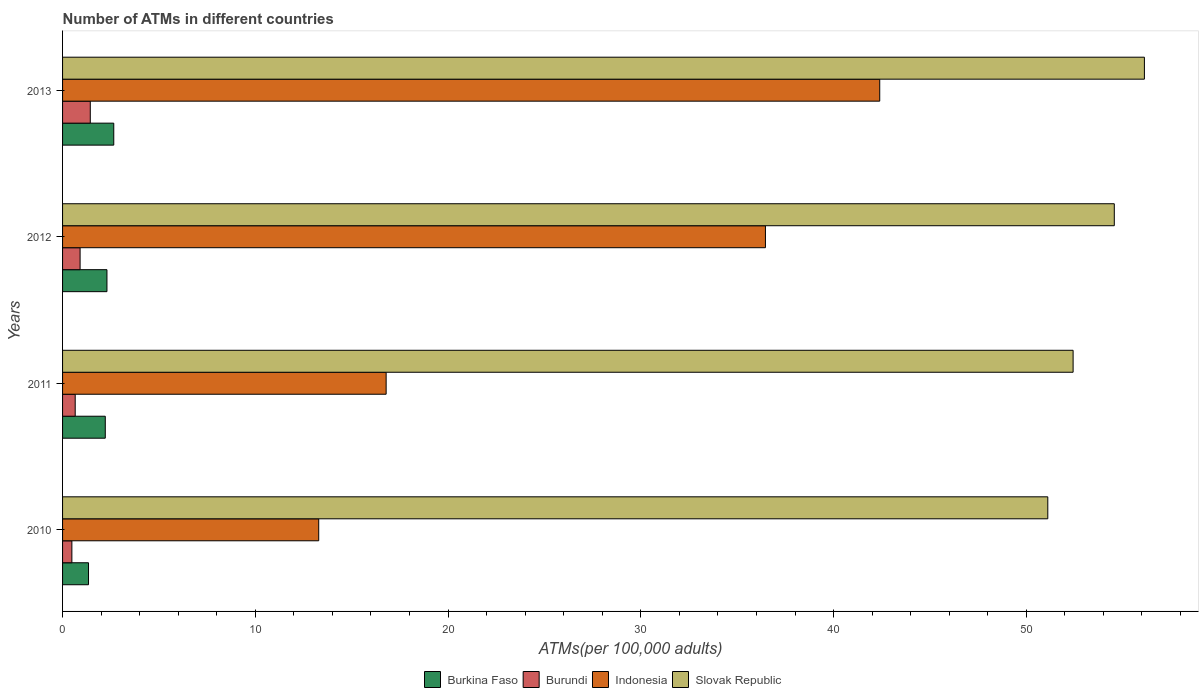In how many cases, is the number of bars for a given year not equal to the number of legend labels?
Ensure brevity in your answer.  0. What is the number of ATMs in Burkina Faso in 2013?
Ensure brevity in your answer.  2.66. Across all years, what is the maximum number of ATMs in Burundi?
Your response must be concise. 1.44. Across all years, what is the minimum number of ATMs in Burundi?
Your answer should be very brief. 0.48. What is the total number of ATMs in Indonesia in the graph?
Offer a very short reply. 108.94. What is the difference between the number of ATMs in Slovak Republic in 2012 and that in 2013?
Offer a very short reply. -1.56. What is the difference between the number of ATMs in Indonesia in 2011 and the number of ATMs in Burundi in 2012?
Keep it short and to the point. 15.88. What is the average number of ATMs in Indonesia per year?
Keep it short and to the point. 27.24. In the year 2012, what is the difference between the number of ATMs in Burkina Faso and number of ATMs in Indonesia?
Your answer should be compact. -34.16. In how many years, is the number of ATMs in Slovak Republic greater than 40 ?
Offer a terse response. 4. What is the ratio of the number of ATMs in Slovak Republic in 2011 to that in 2013?
Your response must be concise. 0.93. Is the number of ATMs in Slovak Republic in 2012 less than that in 2013?
Your answer should be compact. Yes. What is the difference between the highest and the second highest number of ATMs in Burkina Faso?
Ensure brevity in your answer.  0.35. What is the difference between the highest and the lowest number of ATMs in Burkina Faso?
Provide a succinct answer. 1.31. In how many years, is the number of ATMs in Indonesia greater than the average number of ATMs in Indonesia taken over all years?
Make the answer very short. 2. Is the sum of the number of ATMs in Burundi in 2010 and 2011 greater than the maximum number of ATMs in Burkina Faso across all years?
Your answer should be compact. No. Is it the case that in every year, the sum of the number of ATMs in Indonesia and number of ATMs in Burundi is greater than the sum of number of ATMs in Burkina Faso and number of ATMs in Slovak Republic?
Your answer should be very brief. No. What does the 2nd bar from the top in 2011 represents?
Your answer should be very brief. Indonesia. What does the 4th bar from the bottom in 2012 represents?
Ensure brevity in your answer.  Slovak Republic. Is it the case that in every year, the sum of the number of ATMs in Burundi and number of ATMs in Burkina Faso is greater than the number of ATMs in Indonesia?
Offer a terse response. No. How many bars are there?
Your answer should be compact. 16. How many years are there in the graph?
Your answer should be compact. 4. What is the difference between two consecutive major ticks on the X-axis?
Offer a terse response. 10. Are the values on the major ticks of X-axis written in scientific E-notation?
Make the answer very short. No. Does the graph contain any zero values?
Make the answer very short. No. How are the legend labels stacked?
Your answer should be very brief. Horizontal. What is the title of the graph?
Keep it short and to the point. Number of ATMs in different countries. What is the label or title of the X-axis?
Your answer should be compact. ATMs(per 100,0 adults). What is the label or title of the Y-axis?
Your response must be concise. Years. What is the ATMs(per 100,000 adults) in Burkina Faso in 2010?
Your response must be concise. 1.35. What is the ATMs(per 100,000 adults) in Burundi in 2010?
Your answer should be compact. 0.48. What is the ATMs(per 100,000 adults) of Indonesia in 2010?
Keep it short and to the point. 13.29. What is the ATMs(per 100,000 adults) in Slovak Republic in 2010?
Provide a succinct answer. 51.12. What is the ATMs(per 100,000 adults) of Burkina Faso in 2011?
Offer a very short reply. 2.22. What is the ATMs(per 100,000 adults) of Burundi in 2011?
Provide a short and direct response. 0.66. What is the ATMs(per 100,000 adults) of Indonesia in 2011?
Offer a very short reply. 16.79. What is the ATMs(per 100,000 adults) in Slovak Republic in 2011?
Provide a short and direct response. 52.43. What is the ATMs(per 100,000 adults) in Burkina Faso in 2012?
Ensure brevity in your answer.  2.3. What is the ATMs(per 100,000 adults) of Burundi in 2012?
Ensure brevity in your answer.  0.91. What is the ATMs(per 100,000 adults) of Indonesia in 2012?
Ensure brevity in your answer.  36.47. What is the ATMs(per 100,000 adults) of Slovak Republic in 2012?
Give a very brief answer. 54.57. What is the ATMs(per 100,000 adults) of Burkina Faso in 2013?
Provide a succinct answer. 2.66. What is the ATMs(per 100,000 adults) of Burundi in 2013?
Make the answer very short. 1.44. What is the ATMs(per 100,000 adults) of Indonesia in 2013?
Your response must be concise. 42.4. What is the ATMs(per 100,000 adults) of Slovak Republic in 2013?
Keep it short and to the point. 56.13. Across all years, what is the maximum ATMs(per 100,000 adults) in Burkina Faso?
Ensure brevity in your answer.  2.66. Across all years, what is the maximum ATMs(per 100,000 adults) in Burundi?
Offer a very short reply. 1.44. Across all years, what is the maximum ATMs(per 100,000 adults) of Indonesia?
Make the answer very short. 42.4. Across all years, what is the maximum ATMs(per 100,000 adults) in Slovak Republic?
Provide a short and direct response. 56.13. Across all years, what is the minimum ATMs(per 100,000 adults) of Burkina Faso?
Your answer should be compact. 1.35. Across all years, what is the minimum ATMs(per 100,000 adults) of Burundi?
Provide a succinct answer. 0.48. Across all years, what is the minimum ATMs(per 100,000 adults) of Indonesia?
Offer a very short reply. 13.29. Across all years, what is the minimum ATMs(per 100,000 adults) of Slovak Republic?
Your response must be concise. 51.12. What is the total ATMs(per 100,000 adults) in Burkina Faso in the graph?
Offer a terse response. 8.52. What is the total ATMs(per 100,000 adults) of Burundi in the graph?
Offer a terse response. 3.49. What is the total ATMs(per 100,000 adults) of Indonesia in the graph?
Your answer should be compact. 108.94. What is the total ATMs(per 100,000 adults) of Slovak Republic in the graph?
Ensure brevity in your answer.  214.24. What is the difference between the ATMs(per 100,000 adults) of Burkina Faso in 2010 and that in 2011?
Give a very brief answer. -0.87. What is the difference between the ATMs(per 100,000 adults) in Burundi in 2010 and that in 2011?
Offer a terse response. -0.17. What is the difference between the ATMs(per 100,000 adults) in Indonesia in 2010 and that in 2011?
Make the answer very short. -3.5. What is the difference between the ATMs(per 100,000 adults) in Slovak Republic in 2010 and that in 2011?
Your answer should be compact. -1.31. What is the difference between the ATMs(per 100,000 adults) of Burkina Faso in 2010 and that in 2012?
Ensure brevity in your answer.  -0.96. What is the difference between the ATMs(per 100,000 adults) in Burundi in 2010 and that in 2012?
Ensure brevity in your answer.  -0.43. What is the difference between the ATMs(per 100,000 adults) of Indonesia in 2010 and that in 2012?
Keep it short and to the point. -23.18. What is the difference between the ATMs(per 100,000 adults) in Slovak Republic in 2010 and that in 2012?
Your response must be concise. -3.45. What is the difference between the ATMs(per 100,000 adults) of Burkina Faso in 2010 and that in 2013?
Provide a succinct answer. -1.31. What is the difference between the ATMs(per 100,000 adults) of Burundi in 2010 and that in 2013?
Provide a short and direct response. -0.95. What is the difference between the ATMs(per 100,000 adults) in Indonesia in 2010 and that in 2013?
Give a very brief answer. -29.11. What is the difference between the ATMs(per 100,000 adults) in Slovak Republic in 2010 and that in 2013?
Your answer should be compact. -5.01. What is the difference between the ATMs(per 100,000 adults) in Burkina Faso in 2011 and that in 2012?
Offer a very short reply. -0.09. What is the difference between the ATMs(per 100,000 adults) of Burundi in 2011 and that in 2012?
Your answer should be very brief. -0.25. What is the difference between the ATMs(per 100,000 adults) of Indonesia in 2011 and that in 2012?
Offer a terse response. -19.68. What is the difference between the ATMs(per 100,000 adults) in Slovak Republic in 2011 and that in 2012?
Provide a succinct answer. -2.14. What is the difference between the ATMs(per 100,000 adults) in Burkina Faso in 2011 and that in 2013?
Ensure brevity in your answer.  -0.44. What is the difference between the ATMs(per 100,000 adults) of Burundi in 2011 and that in 2013?
Offer a terse response. -0.78. What is the difference between the ATMs(per 100,000 adults) of Indonesia in 2011 and that in 2013?
Provide a short and direct response. -25.61. What is the difference between the ATMs(per 100,000 adults) of Slovak Republic in 2011 and that in 2013?
Ensure brevity in your answer.  -3.7. What is the difference between the ATMs(per 100,000 adults) in Burkina Faso in 2012 and that in 2013?
Offer a very short reply. -0.35. What is the difference between the ATMs(per 100,000 adults) of Burundi in 2012 and that in 2013?
Your answer should be compact. -0.53. What is the difference between the ATMs(per 100,000 adults) of Indonesia in 2012 and that in 2013?
Provide a short and direct response. -5.93. What is the difference between the ATMs(per 100,000 adults) in Slovak Republic in 2012 and that in 2013?
Your answer should be very brief. -1.56. What is the difference between the ATMs(per 100,000 adults) of Burkina Faso in 2010 and the ATMs(per 100,000 adults) of Burundi in 2011?
Keep it short and to the point. 0.69. What is the difference between the ATMs(per 100,000 adults) of Burkina Faso in 2010 and the ATMs(per 100,000 adults) of Indonesia in 2011?
Your answer should be very brief. -15.44. What is the difference between the ATMs(per 100,000 adults) of Burkina Faso in 2010 and the ATMs(per 100,000 adults) of Slovak Republic in 2011?
Your response must be concise. -51.08. What is the difference between the ATMs(per 100,000 adults) in Burundi in 2010 and the ATMs(per 100,000 adults) in Indonesia in 2011?
Provide a short and direct response. -16.31. What is the difference between the ATMs(per 100,000 adults) in Burundi in 2010 and the ATMs(per 100,000 adults) in Slovak Republic in 2011?
Offer a terse response. -51.95. What is the difference between the ATMs(per 100,000 adults) in Indonesia in 2010 and the ATMs(per 100,000 adults) in Slovak Republic in 2011?
Give a very brief answer. -39.14. What is the difference between the ATMs(per 100,000 adults) of Burkina Faso in 2010 and the ATMs(per 100,000 adults) of Burundi in 2012?
Offer a terse response. 0.44. What is the difference between the ATMs(per 100,000 adults) of Burkina Faso in 2010 and the ATMs(per 100,000 adults) of Indonesia in 2012?
Your answer should be compact. -35.12. What is the difference between the ATMs(per 100,000 adults) of Burkina Faso in 2010 and the ATMs(per 100,000 adults) of Slovak Republic in 2012?
Your response must be concise. -53.22. What is the difference between the ATMs(per 100,000 adults) of Burundi in 2010 and the ATMs(per 100,000 adults) of Indonesia in 2012?
Offer a terse response. -35.98. What is the difference between the ATMs(per 100,000 adults) in Burundi in 2010 and the ATMs(per 100,000 adults) in Slovak Republic in 2012?
Your answer should be very brief. -54.08. What is the difference between the ATMs(per 100,000 adults) in Indonesia in 2010 and the ATMs(per 100,000 adults) in Slovak Republic in 2012?
Give a very brief answer. -41.28. What is the difference between the ATMs(per 100,000 adults) of Burkina Faso in 2010 and the ATMs(per 100,000 adults) of Burundi in 2013?
Provide a short and direct response. -0.09. What is the difference between the ATMs(per 100,000 adults) in Burkina Faso in 2010 and the ATMs(per 100,000 adults) in Indonesia in 2013?
Ensure brevity in your answer.  -41.05. What is the difference between the ATMs(per 100,000 adults) in Burkina Faso in 2010 and the ATMs(per 100,000 adults) in Slovak Republic in 2013?
Provide a succinct answer. -54.78. What is the difference between the ATMs(per 100,000 adults) of Burundi in 2010 and the ATMs(per 100,000 adults) of Indonesia in 2013?
Keep it short and to the point. -41.91. What is the difference between the ATMs(per 100,000 adults) of Burundi in 2010 and the ATMs(per 100,000 adults) of Slovak Republic in 2013?
Offer a terse response. -55.64. What is the difference between the ATMs(per 100,000 adults) in Indonesia in 2010 and the ATMs(per 100,000 adults) in Slovak Republic in 2013?
Ensure brevity in your answer.  -42.84. What is the difference between the ATMs(per 100,000 adults) in Burkina Faso in 2011 and the ATMs(per 100,000 adults) in Burundi in 2012?
Give a very brief answer. 1.31. What is the difference between the ATMs(per 100,000 adults) in Burkina Faso in 2011 and the ATMs(per 100,000 adults) in Indonesia in 2012?
Offer a terse response. -34.25. What is the difference between the ATMs(per 100,000 adults) of Burkina Faso in 2011 and the ATMs(per 100,000 adults) of Slovak Republic in 2012?
Provide a succinct answer. -52.35. What is the difference between the ATMs(per 100,000 adults) in Burundi in 2011 and the ATMs(per 100,000 adults) in Indonesia in 2012?
Provide a short and direct response. -35.81. What is the difference between the ATMs(per 100,000 adults) of Burundi in 2011 and the ATMs(per 100,000 adults) of Slovak Republic in 2012?
Your response must be concise. -53.91. What is the difference between the ATMs(per 100,000 adults) of Indonesia in 2011 and the ATMs(per 100,000 adults) of Slovak Republic in 2012?
Your answer should be very brief. -37.78. What is the difference between the ATMs(per 100,000 adults) of Burkina Faso in 2011 and the ATMs(per 100,000 adults) of Burundi in 2013?
Offer a very short reply. 0.78. What is the difference between the ATMs(per 100,000 adults) of Burkina Faso in 2011 and the ATMs(per 100,000 adults) of Indonesia in 2013?
Provide a short and direct response. -40.18. What is the difference between the ATMs(per 100,000 adults) in Burkina Faso in 2011 and the ATMs(per 100,000 adults) in Slovak Republic in 2013?
Your answer should be very brief. -53.91. What is the difference between the ATMs(per 100,000 adults) in Burundi in 2011 and the ATMs(per 100,000 adults) in Indonesia in 2013?
Offer a very short reply. -41.74. What is the difference between the ATMs(per 100,000 adults) of Burundi in 2011 and the ATMs(per 100,000 adults) of Slovak Republic in 2013?
Offer a terse response. -55.47. What is the difference between the ATMs(per 100,000 adults) of Indonesia in 2011 and the ATMs(per 100,000 adults) of Slovak Republic in 2013?
Your answer should be very brief. -39.34. What is the difference between the ATMs(per 100,000 adults) of Burkina Faso in 2012 and the ATMs(per 100,000 adults) of Burundi in 2013?
Provide a succinct answer. 0.87. What is the difference between the ATMs(per 100,000 adults) in Burkina Faso in 2012 and the ATMs(per 100,000 adults) in Indonesia in 2013?
Make the answer very short. -40.09. What is the difference between the ATMs(per 100,000 adults) of Burkina Faso in 2012 and the ATMs(per 100,000 adults) of Slovak Republic in 2013?
Keep it short and to the point. -53.82. What is the difference between the ATMs(per 100,000 adults) in Burundi in 2012 and the ATMs(per 100,000 adults) in Indonesia in 2013?
Your answer should be very brief. -41.49. What is the difference between the ATMs(per 100,000 adults) in Burundi in 2012 and the ATMs(per 100,000 adults) in Slovak Republic in 2013?
Give a very brief answer. -55.22. What is the difference between the ATMs(per 100,000 adults) of Indonesia in 2012 and the ATMs(per 100,000 adults) of Slovak Republic in 2013?
Make the answer very short. -19.66. What is the average ATMs(per 100,000 adults) of Burkina Faso per year?
Ensure brevity in your answer.  2.13. What is the average ATMs(per 100,000 adults) of Burundi per year?
Provide a short and direct response. 0.87. What is the average ATMs(per 100,000 adults) in Indonesia per year?
Keep it short and to the point. 27.24. What is the average ATMs(per 100,000 adults) in Slovak Republic per year?
Your answer should be compact. 53.56. In the year 2010, what is the difference between the ATMs(per 100,000 adults) of Burkina Faso and ATMs(per 100,000 adults) of Burundi?
Provide a short and direct response. 0.86. In the year 2010, what is the difference between the ATMs(per 100,000 adults) in Burkina Faso and ATMs(per 100,000 adults) in Indonesia?
Give a very brief answer. -11.94. In the year 2010, what is the difference between the ATMs(per 100,000 adults) in Burkina Faso and ATMs(per 100,000 adults) in Slovak Republic?
Your answer should be compact. -49.77. In the year 2010, what is the difference between the ATMs(per 100,000 adults) of Burundi and ATMs(per 100,000 adults) of Indonesia?
Give a very brief answer. -12.81. In the year 2010, what is the difference between the ATMs(per 100,000 adults) of Burundi and ATMs(per 100,000 adults) of Slovak Republic?
Offer a very short reply. -50.63. In the year 2010, what is the difference between the ATMs(per 100,000 adults) in Indonesia and ATMs(per 100,000 adults) in Slovak Republic?
Provide a succinct answer. -37.83. In the year 2011, what is the difference between the ATMs(per 100,000 adults) in Burkina Faso and ATMs(per 100,000 adults) in Burundi?
Provide a succinct answer. 1.56. In the year 2011, what is the difference between the ATMs(per 100,000 adults) of Burkina Faso and ATMs(per 100,000 adults) of Indonesia?
Offer a very short reply. -14.57. In the year 2011, what is the difference between the ATMs(per 100,000 adults) of Burkina Faso and ATMs(per 100,000 adults) of Slovak Republic?
Your answer should be very brief. -50.21. In the year 2011, what is the difference between the ATMs(per 100,000 adults) of Burundi and ATMs(per 100,000 adults) of Indonesia?
Your answer should be compact. -16.13. In the year 2011, what is the difference between the ATMs(per 100,000 adults) of Burundi and ATMs(per 100,000 adults) of Slovak Republic?
Your answer should be very brief. -51.77. In the year 2011, what is the difference between the ATMs(per 100,000 adults) of Indonesia and ATMs(per 100,000 adults) of Slovak Republic?
Offer a terse response. -35.64. In the year 2012, what is the difference between the ATMs(per 100,000 adults) of Burkina Faso and ATMs(per 100,000 adults) of Burundi?
Provide a succinct answer. 1.39. In the year 2012, what is the difference between the ATMs(per 100,000 adults) of Burkina Faso and ATMs(per 100,000 adults) of Indonesia?
Your response must be concise. -34.16. In the year 2012, what is the difference between the ATMs(per 100,000 adults) of Burkina Faso and ATMs(per 100,000 adults) of Slovak Republic?
Ensure brevity in your answer.  -52.26. In the year 2012, what is the difference between the ATMs(per 100,000 adults) in Burundi and ATMs(per 100,000 adults) in Indonesia?
Offer a very short reply. -35.56. In the year 2012, what is the difference between the ATMs(per 100,000 adults) of Burundi and ATMs(per 100,000 adults) of Slovak Republic?
Provide a succinct answer. -53.66. In the year 2012, what is the difference between the ATMs(per 100,000 adults) in Indonesia and ATMs(per 100,000 adults) in Slovak Republic?
Provide a succinct answer. -18.1. In the year 2013, what is the difference between the ATMs(per 100,000 adults) of Burkina Faso and ATMs(per 100,000 adults) of Burundi?
Offer a very short reply. 1.22. In the year 2013, what is the difference between the ATMs(per 100,000 adults) in Burkina Faso and ATMs(per 100,000 adults) in Indonesia?
Your answer should be very brief. -39.74. In the year 2013, what is the difference between the ATMs(per 100,000 adults) of Burkina Faso and ATMs(per 100,000 adults) of Slovak Republic?
Your answer should be compact. -53.47. In the year 2013, what is the difference between the ATMs(per 100,000 adults) of Burundi and ATMs(per 100,000 adults) of Indonesia?
Provide a succinct answer. -40.96. In the year 2013, what is the difference between the ATMs(per 100,000 adults) of Burundi and ATMs(per 100,000 adults) of Slovak Republic?
Offer a terse response. -54.69. In the year 2013, what is the difference between the ATMs(per 100,000 adults) of Indonesia and ATMs(per 100,000 adults) of Slovak Republic?
Provide a short and direct response. -13.73. What is the ratio of the ATMs(per 100,000 adults) in Burkina Faso in 2010 to that in 2011?
Make the answer very short. 0.61. What is the ratio of the ATMs(per 100,000 adults) of Burundi in 2010 to that in 2011?
Make the answer very short. 0.74. What is the ratio of the ATMs(per 100,000 adults) of Indonesia in 2010 to that in 2011?
Your answer should be compact. 0.79. What is the ratio of the ATMs(per 100,000 adults) of Slovak Republic in 2010 to that in 2011?
Offer a terse response. 0.97. What is the ratio of the ATMs(per 100,000 adults) in Burkina Faso in 2010 to that in 2012?
Give a very brief answer. 0.58. What is the ratio of the ATMs(per 100,000 adults) of Burundi in 2010 to that in 2012?
Provide a short and direct response. 0.53. What is the ratio of the ATMs(per 100,000 adults) of Indonesia in 2010 to that in 2012?
Your answer should be compact. 0.36. What is the ratio of the ATMs(per 100,000 adults) of Slovak Republic in 2010 to that in 2012?
Provide a short and direct response. 0.94. What is the ratio of the ATMs(per 100,000 adults) in Burkina Faso in 2010 to that in 2013?
Keep it short and to the point. 0.51. What is the ratio of the ATMs(per 100,000 adults) in Burundi in 2010 to that in 2013?
Your answer should be compact. 0.34. What is the ratio of the ATMs(per 100,000 adults) in Indonesia in 2010 to that in 2013?
Your answer should be compact. 0.31. What is the ratio of the ATMs(per 100,000 adults) in Slovak Republic in 2010 to that in 2013?
Offer a terse response. 0.91. What is the ratio of the ATMs(per 100,000 adults) of Burkina Faso in 2011 to that in 2012?
Make the answer very short. 0.96. What is the ratio of the ATMs(per 100,000 adults) in Burundi in 2011 to that in 2012?
Provide a succinct answer. 0.72. What is the ratio of the ATMs(per 100,000 adults) in Indonesia in 2011 to that in 2012?
Provide a short and direct response. 0.46. What is the ratio of the ATMs(per 100,000 adults) of Slovak Republic in 2011 to that in 2012?
Your answer should be very brief. 0.96. What is the ratio of the ATMs(per 100,000 adults) of Burkina Faso in 2011 to that in 2013?
Your response must be concise. 0.83. What is the ratio of the ATMs(per 100,000 adults) in Burundi in 2011 to that in 2013?
Offer a terse response. 0.46. What is the ratio of the ATMs(per 100,000 adults) in Indonesia in 2011 to that in 2013?
Provide a succinct answer. 0.4. What is the ratio of the ATMs(per 100,000 adults) of Slovak Republic in 2011 to that in 2013?
Make the answer very short. 0.93. What is the ratio of the ATMs(per 100,000 adults) in Burkina Faso in 2012 to that in 2013?
Your answer should be very brief. 0.87. What is the ratio of the ATMs(per 100,000 adults) of Burundi in 2012 to that in 2013?
Give a very brief answer. 0.63. What is the ratio of the ATMs(per 100,000 adults) in Indonesia in 2012 to that in 2013?
Keep it short and to the point. 0.86. What is the ratio of the ATMs(per 100,000 adults) of Slovak Republic in 2012 to that in 2013?
Offer a terse response. 0.97. What is the difference between the highest and the second highest ATMs(per 100,000 adults) in Burkina Faso?
Keep it short and to the point. 0.35. What is the difference between the highest and the second highest ATMs(per 100,000 adults) in Burundi?
Ensure brevity in your answer.  0.53. What is the difference between the highest and the second highest ATMs(per 100,000 adults) in Indonesia?
Offer a terse response. 5.93. What is the difference between the highest and the second highest ATMs(per 100,000 adults) in Slovak Republic?
Keep it short and to the point. 1.56. What is the difference between the highest and the lowest ATMs(per 100,000 adults) in Burkina Faso?
Ensure brevity in your answer.  1.31. What is the difference between the highest and the lowest ATMs(per 100,000 adults) in Burundi?
Provide a succinct answer. 0.95. What is the difference between the highest and the lowest ATMs(per 100,000 adults) in Indonesia?
Your answer should be compact. 29.11. What is the difference between the highest and the lowest ATMs(per 100,000 adults) of Slovak Republic?
Offer a very short reply. 5.01. 